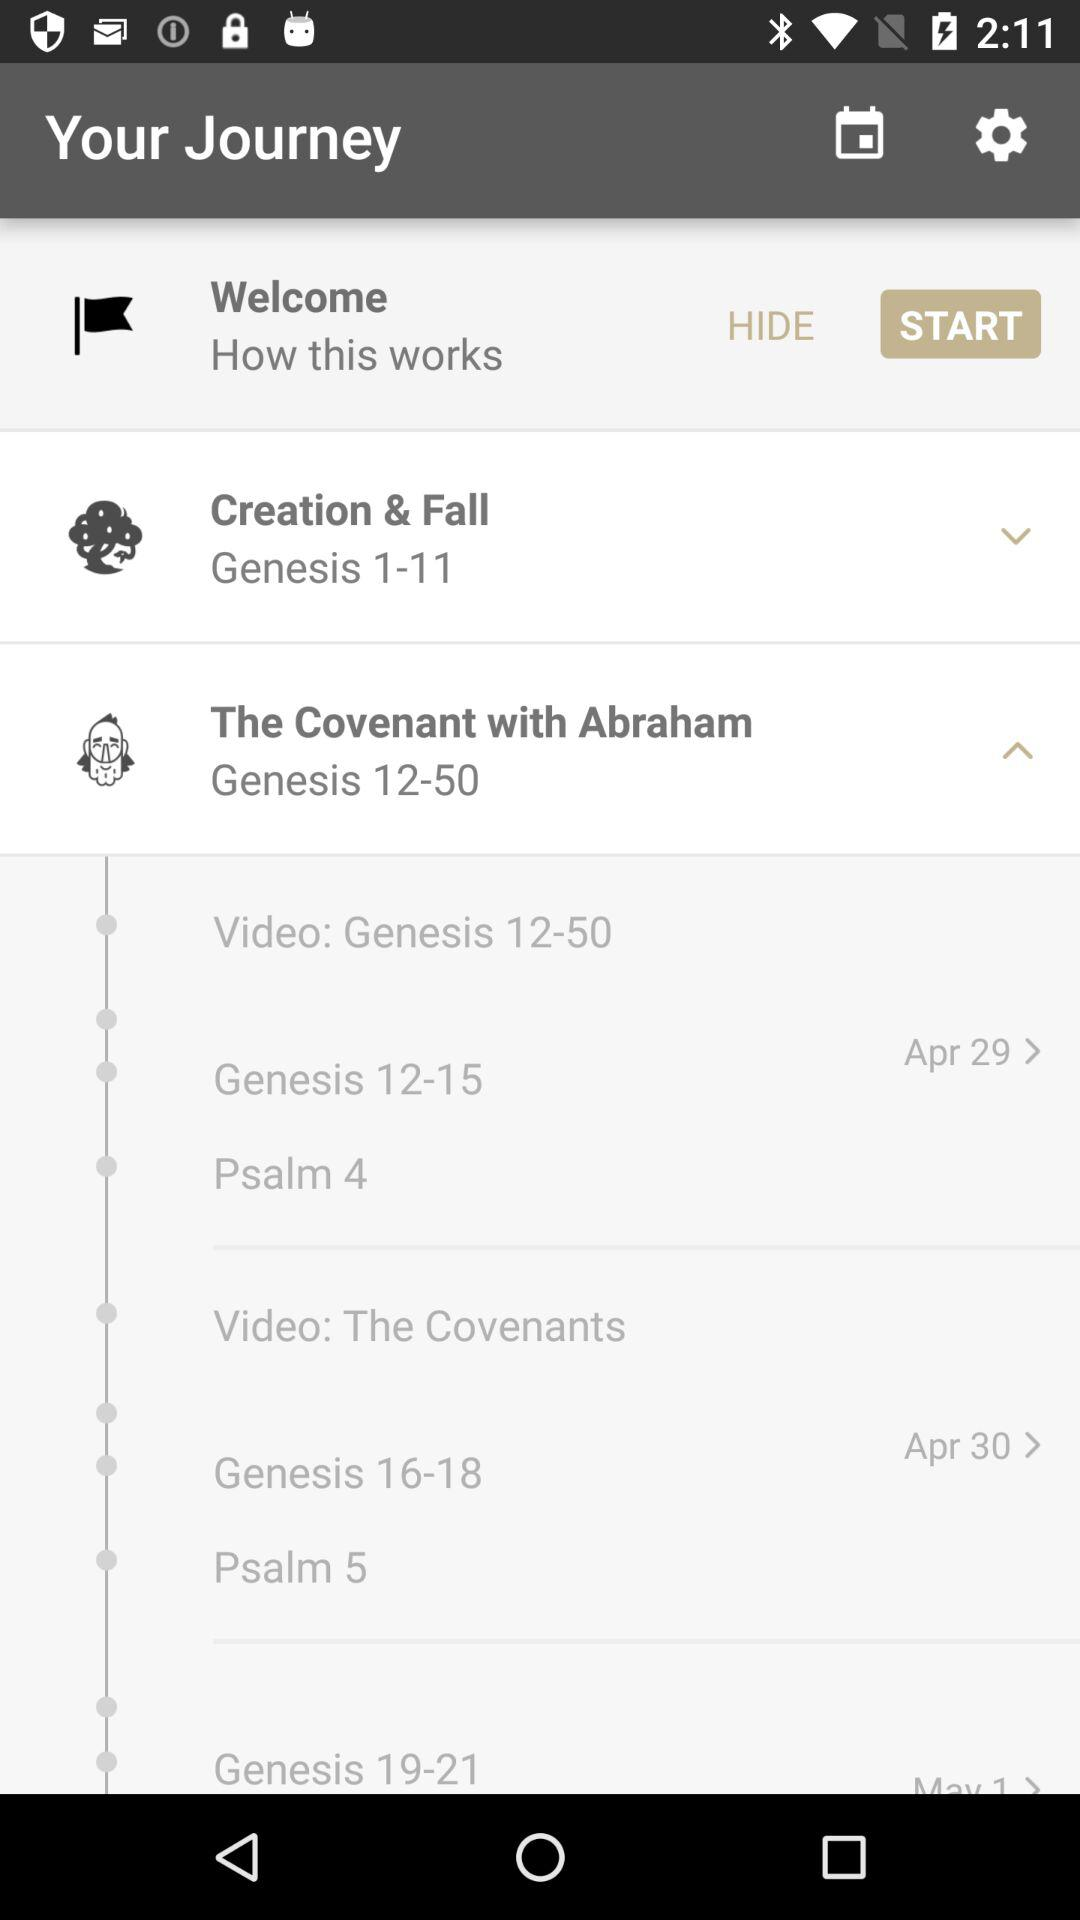What is the title of Genesis 12-50? The title is "The Covenant with Abraham". 